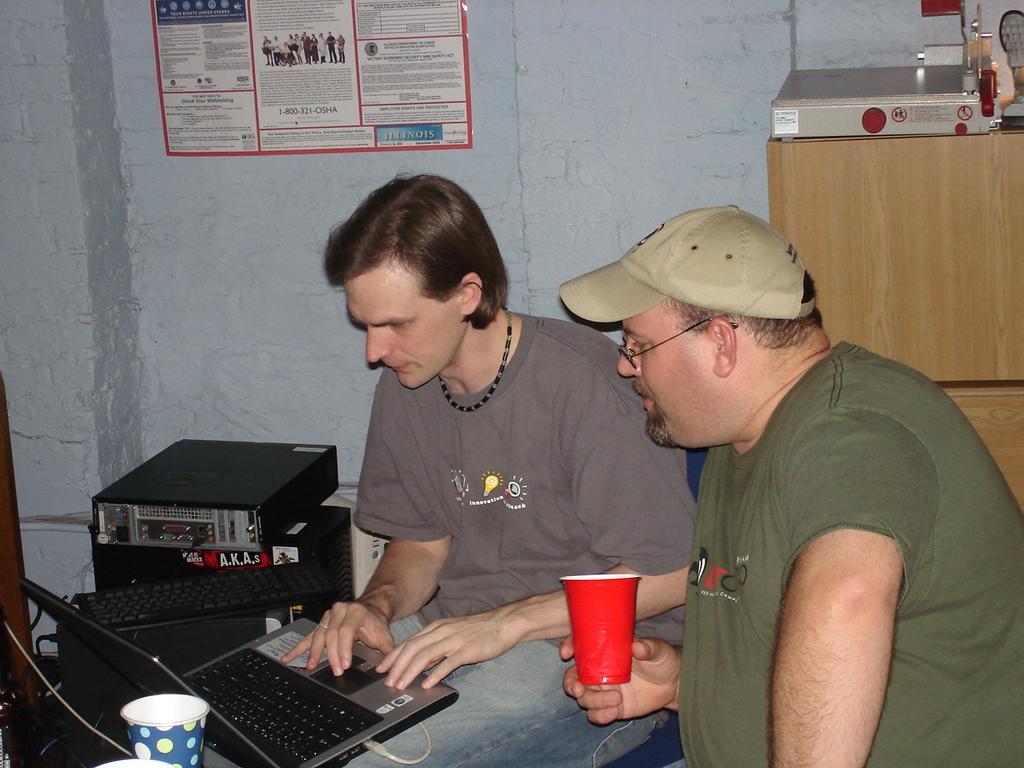Describe this image in one or two sentences. In this image there are two persons sitting on chairs, one person is holding a laptop and another is holding a glass, in the background there are electrical devices and there is a wall for that wall there is a poster. 